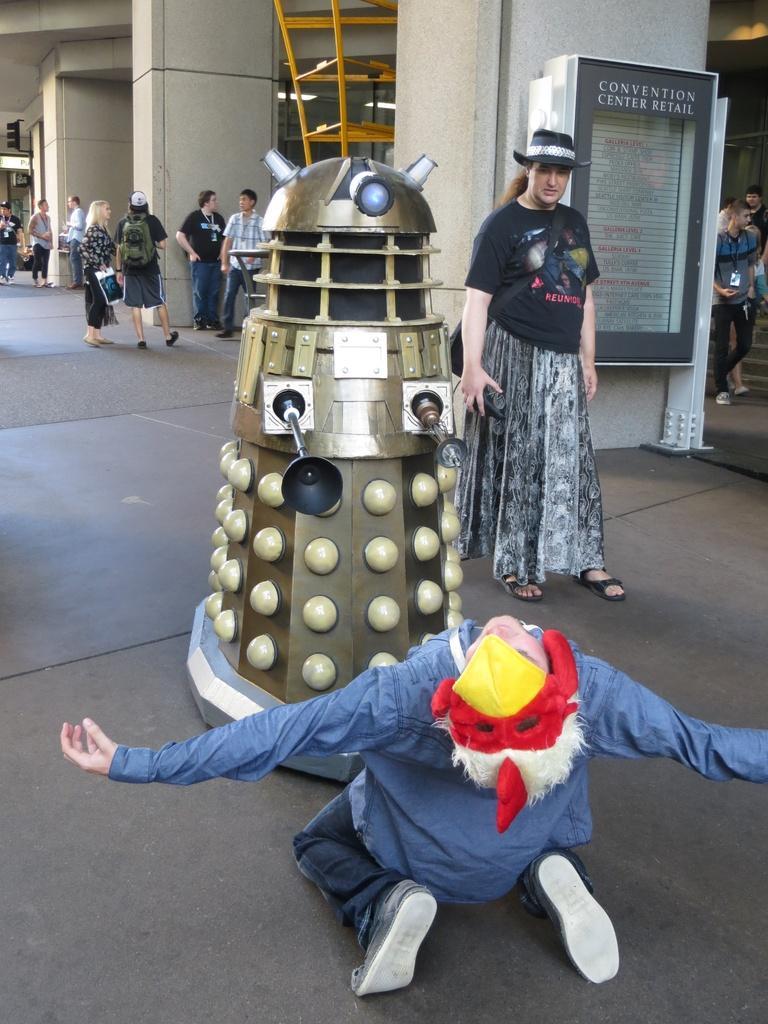How would you summarize this image in a sentence or two? In the picture I can see people are standing on the ground among them one person in the front is kneeling down on the ground. In the background I can see lights on the ceiling and some other objects on the floor. 